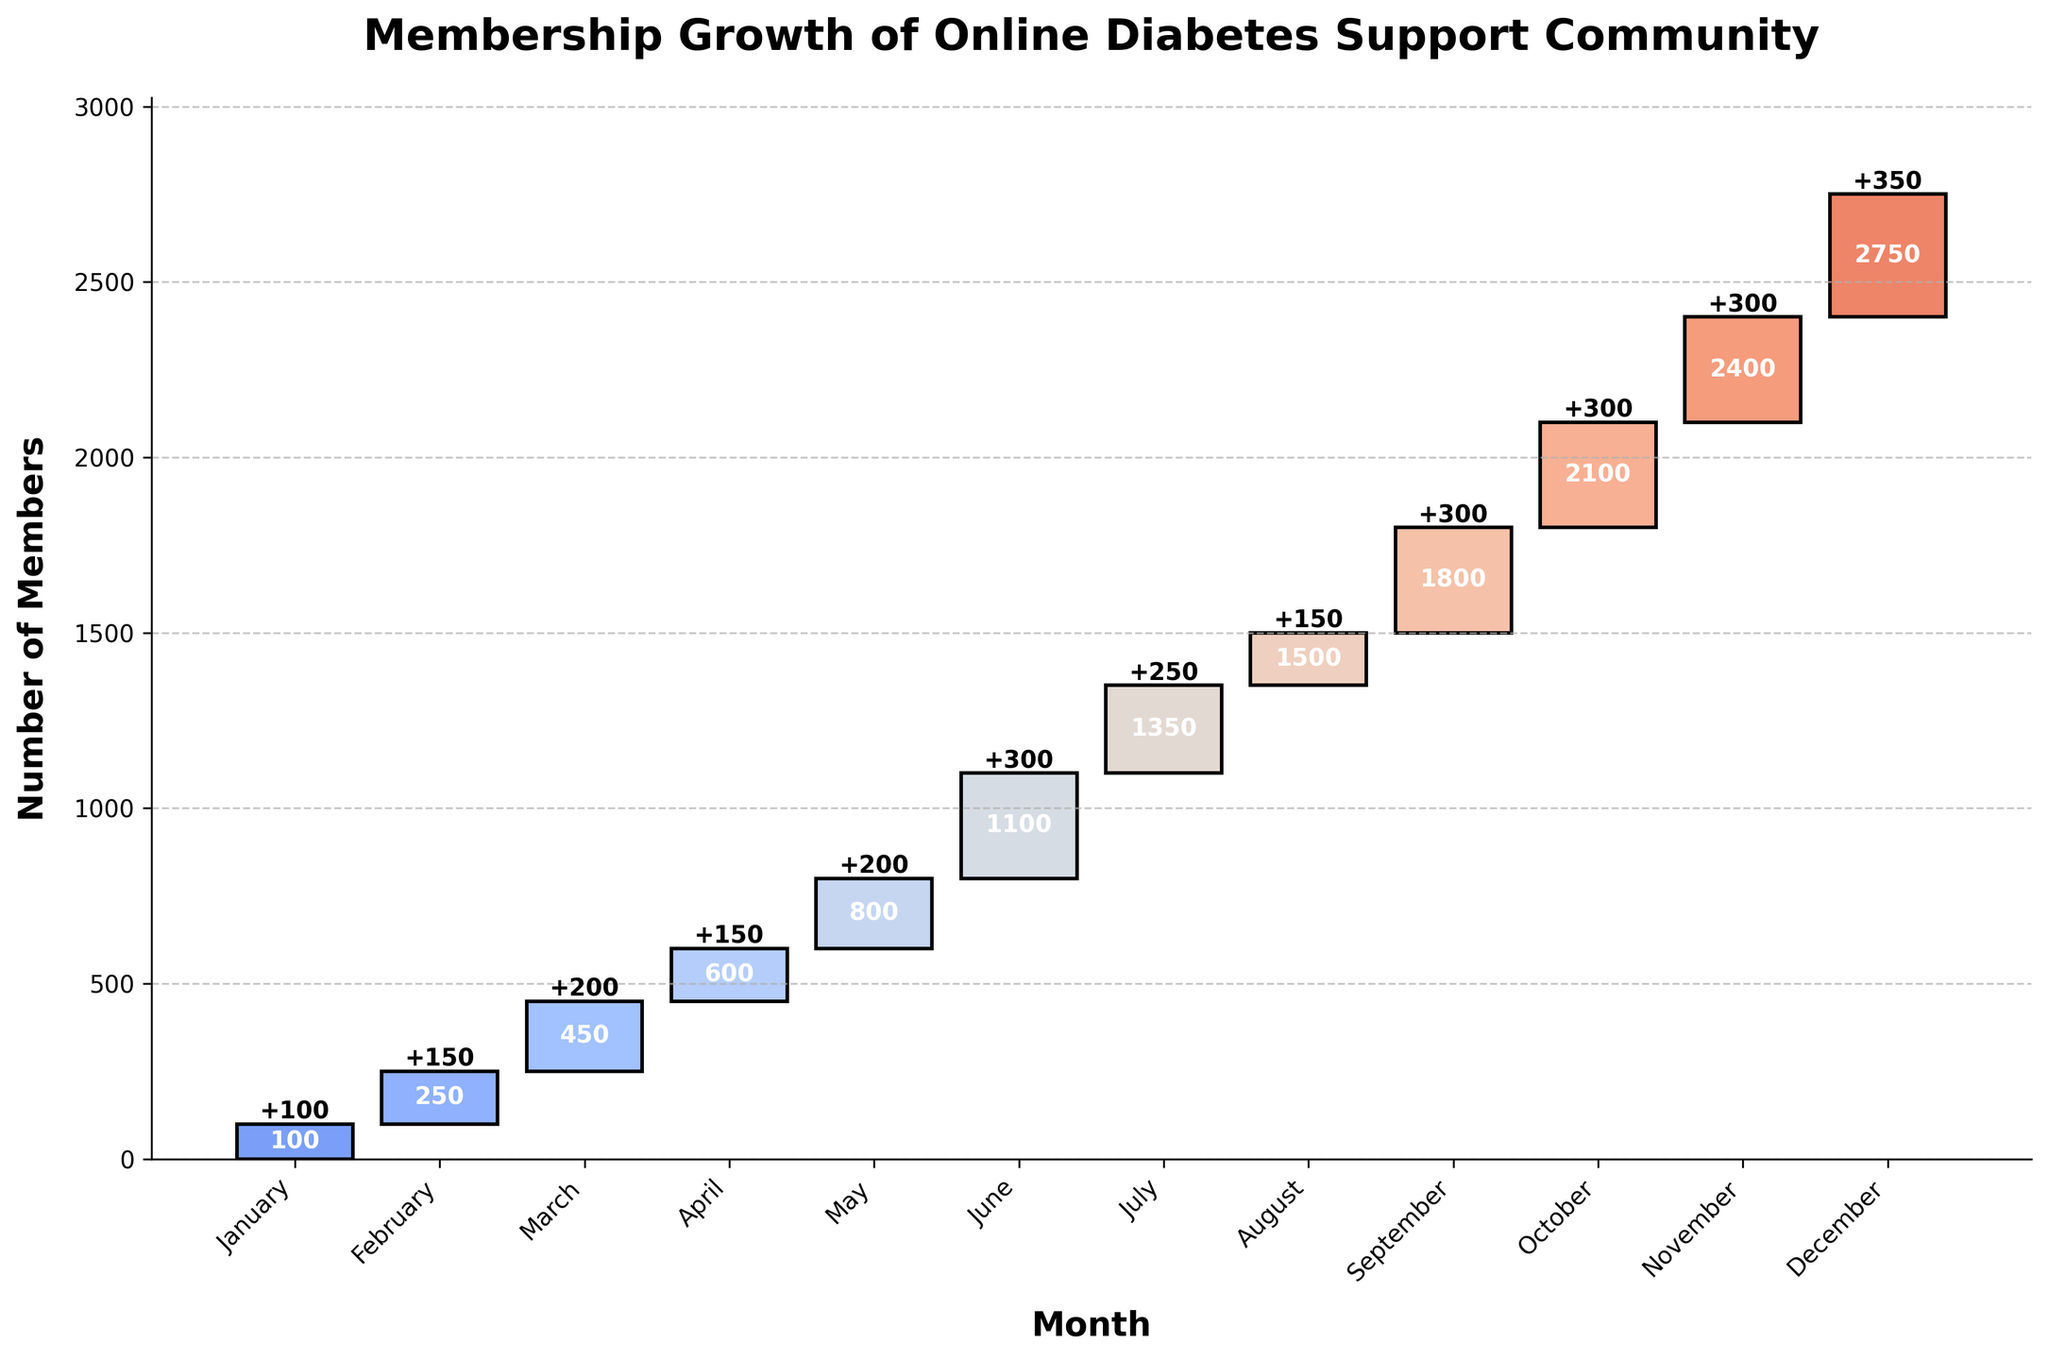What is the title of the chart? The title is displayed at the top of the chart, indicating the main subject it is depicting.
Answer: Membership Growth of Online Diabetes Support Community During which month did the community observe the highest increase in members? The month with the highest increase is indicated by the tallest bar, where the monthly change value is the greatest.
Answer: December What is the total number of members by the end of the year? The total number of members by the end is labeled on top of the last bar, representing the sum of all monthly increases.
Answer: 2750 Which months had a membership increase of 300 members? The months with an increase of 300 members have bars labeled with a +300 change.
Answer: June, September, October, November How many members joined between March and April collectively? Sum the changes for March and April by adding the respective values for these months.
Answer: 350 What is the total membership increase during the summer months June, July, and August? Sum the changes for the summer months to get the total increase: 300 (June) + 250 (July) + 150 (August).
Answer: 700 Was the membership increase in February greater than that in August? Compare the change values of February and August to determine which is larger.
Answer: Yes Which month had the smallest growth in membership? The smallest growth is indicated by the shortest bar and smallest change value.
Answer: August If you sum the membership increases from January to March, how many members joined? Sum the changes for January, February, and March to find the total increase: 100 + 150 + 200.
Answer: 450 How does the membership growth in November compare to that in July? Compare the changes in both months to assess which has a higher membership increase.
Answer: Equal 